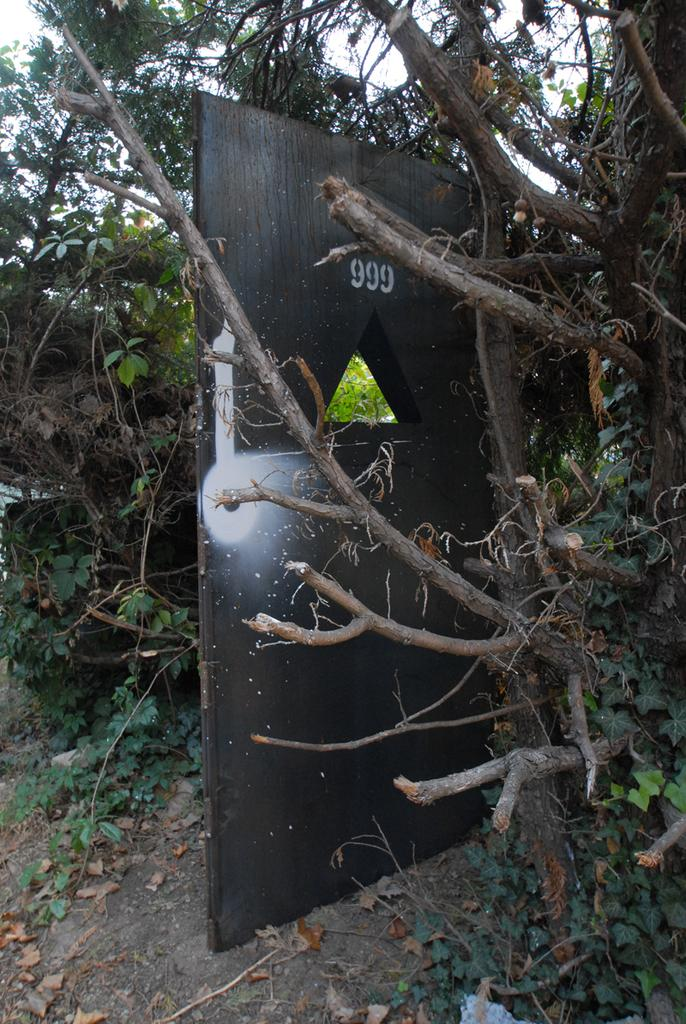What is located at the front of the image? There is a tree in the front of the image. What can be seen in the center of the image? There is a board in the center of the image. What is on the ground in the image? Dry leaves are present on the ground. What is visible in the background of the image? There are trees in the background of the image. What type of coil is used to polish the stage in the image? There is no stage or coil present in the image. What color is the polish applied to the tree in the image? There is no polish applied to the tree in the image; it is a natural tree. 